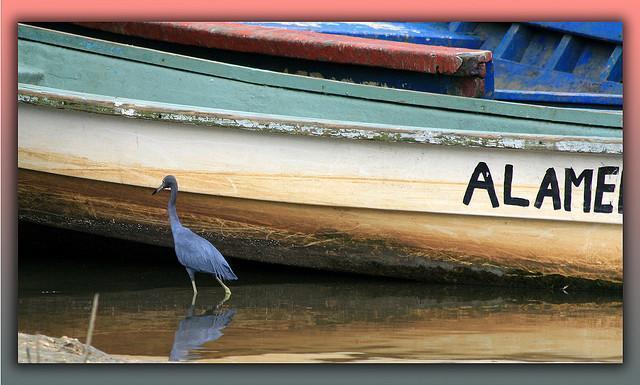Verify the accuracy of this image caption: "The boat is beside the bird.".
Answer yes or no. Yes. 